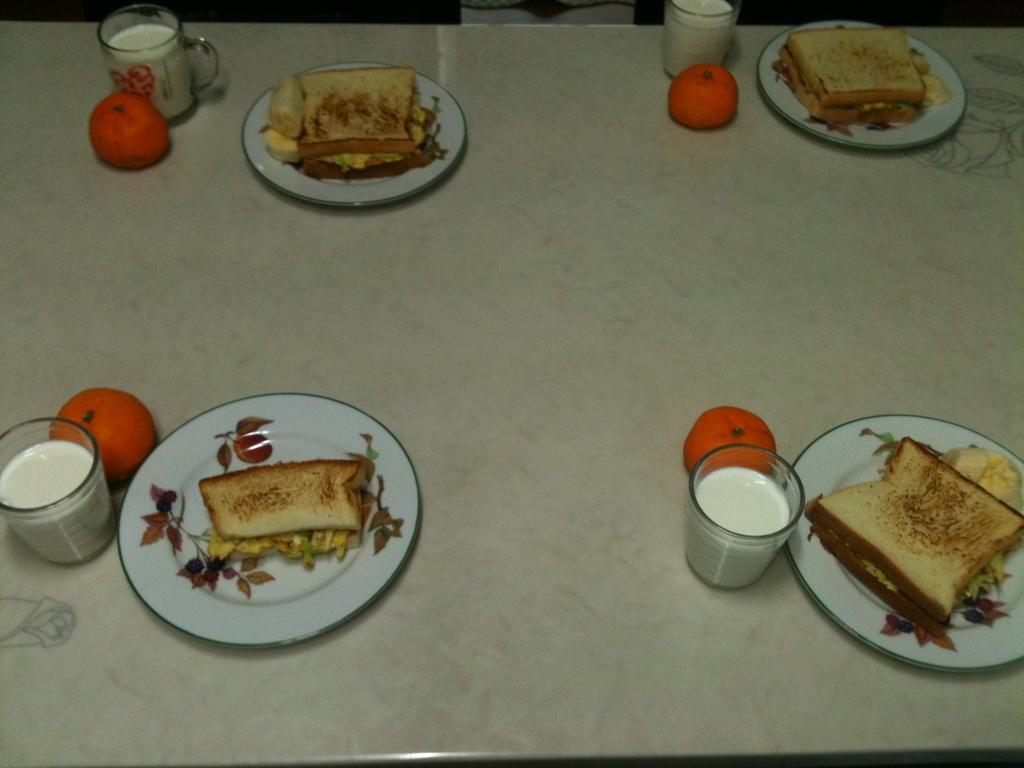How would you summarize this image in a sentence or two? In this image I can see a dining table and on the table I can see few plates with food items in them, few glasses with liquids in them and few fruits which are orange in color. 